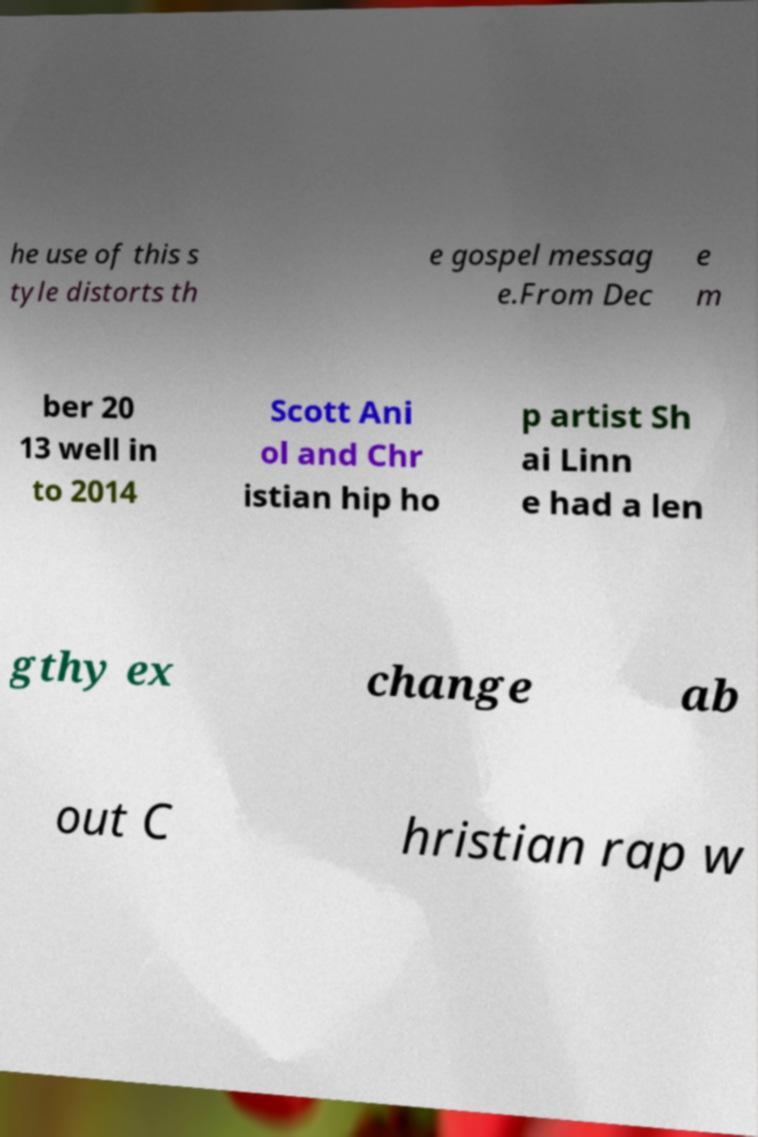Could you extract and type out the text from this image? he use of this s tyle distorts th e gospel messag e.From Dec e m ber 20 13 well in to 2014 Scott Ani ol and Chr istian hip ho p artist Sh ai Linn e had a len gthy ex change ab out C hristian rap w 